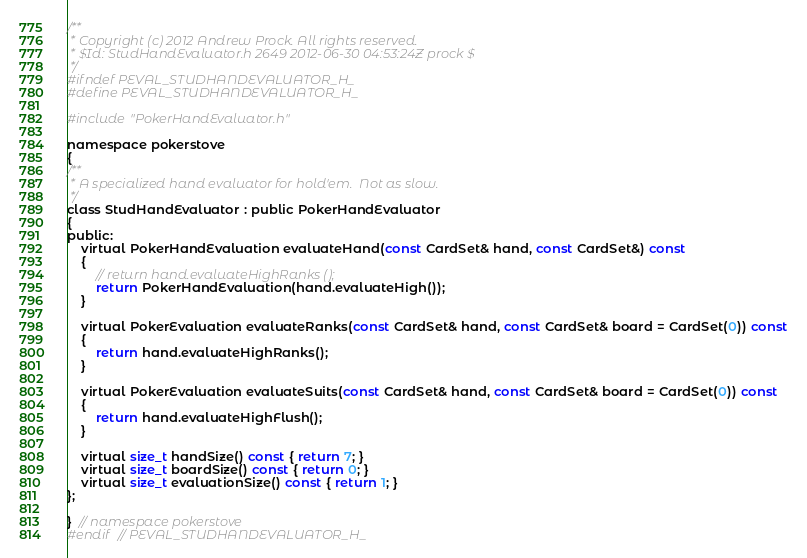<code> <loc_0><loc_0><loc_500><loc_500><_C_>/**
 * Copyright (c) 2012 Andrew Prock. All rights reserved.
 * $Id: StudHandEvaluator.h 2649 2012-06-30 04:53:24Z prock $
 */
#ifndef PEVAL_STUDHANDEVALUATOR_H_
#define PEVAL_STUDHANDEVALUATOR_H_

#include "PokerHandEvaluator.h"

namespace pokerstove
{
/**
 * A specialized hand evaluator for hold'em.  Not as slow.
 */
class StudHandEvaluator : public PokerHandEvaluator
{
public:
    virtual PokerHandEvaluation evaluateHand(const CardSet& hand, const CardSet&) const
    {
        // return hand.evaluateHighRanks ();
        return PokerHandEvaluation(hand.evaluateHigh());
    }

    virtual PokerEvaluation evaluateRanks(const CardSet& hand, const CardSet& board = CardSet(0)) const
    {
        return hand.evaluateHighRanks();
    }

    virtual PokerEvaluation evaluateSuits(const CardSet& hand, const CardSet& board = CardSet(0)) const
    {
        return hand.evaluateHighFlush();
    }

    virtual size_t handSize() const { return 7; }
    virtual size_t boardSize() const { return 0; }
    virtual size_t evaluationSize() const { return 1; }
};

}  // namespace pokerstove
#endif  // PEVAL_STUDHANDEVALUATOR_H_
</code> 